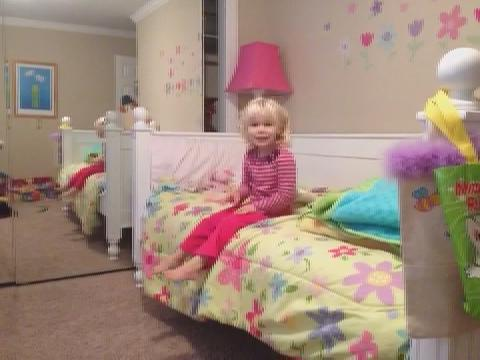Question: where does this picture take place?
Choices:
A. Living room.
B. Carnival.
C. Bedroom.
D. Kitchen.
Answer with the letter. Answer: C Question: what is the little girl sitting on?
Choices:
A. Bed.
B. Floor.
C. Bike.
D. Car seat.
Answer with the letter. Answer: A Question: what color is the lamp shade?
Choices:
A. Red.
B. Pink.
C. Maroon.
D. Purple.
Answer with the letter. Answer: B Question: what color are the girls pants?
Choices:
A. Red.
B. Maroon.
C. Rose.
D. Pink.
Answer with the letter. Answer: D Question: what side of the picture is the mirror on?
Choices:
A. Right.
B. Kiddie corner.
C. Left.
D. Left corner.
Answer with the letter. Answer: C Question: what is on the wall behind the little girl?
Choices:
A. Painting.
B. Flowers.
C. Sconce.
D. Candles.
Answer with the letter. Answer: B Question: how many people are in the picture?
Choices:
A. Zero.
B. Two.
C. One.
D. Three.
Answer with the letter. Answer: C 